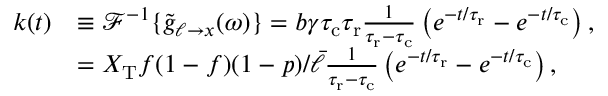Convert formula to latex. <formula><loc_0><loc_0><loc_500><loc_500>\begin{array} { r l } { k ( t ) } & { \equiv \mathcal { F } ^ { - 1 } \{ \tilde { g } _ { \ell \to x } ( \omega ) \} = b \gamma { \tau _ { c } } { \tau _ { r } } \frac { 1 } { { \tau _ { r } } - { \tau _ { c } } } \left ( e ^ { - t / { \tau _ { r } } } - e ^ { - t / { \tau _ { c } } } \right ) , } \\ & { = X _ { T } f ( 1 - f ) ( 1 - p ) / \bar { \ell } \frac { 1 } { { \tau _ { r } } - { \tau _ { c } } } \left ( e ^ { - t / { \tau _ { r } } } - e ^ { - t / { \tau _ { c } } } \right ) , } \end{array}</formula> 